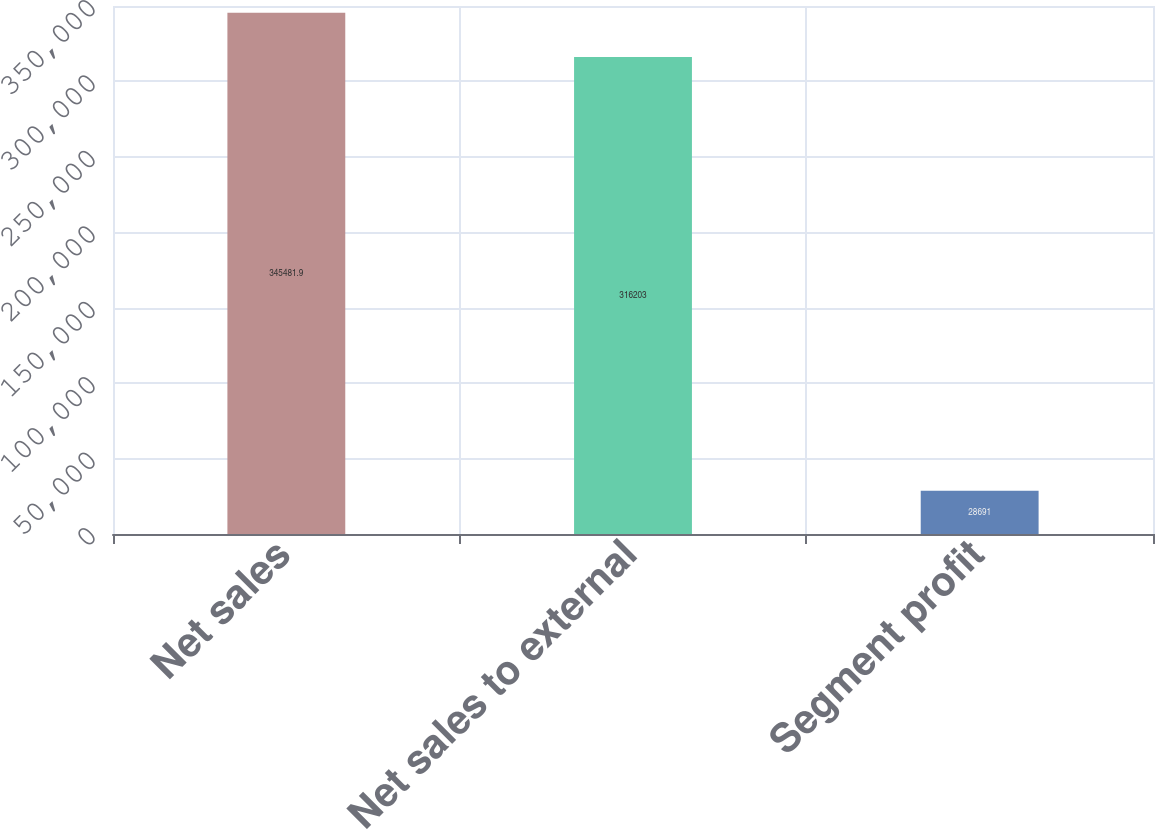Convert chart. <chart><loc_0><loc_0><loc_500><loc_500><bar_chart><fcel>Net sales<fcel>Net sales to external<fcel>Segment profit<nl><fcel>345482<fcel>316203<fcel>28691<nl></chart> 